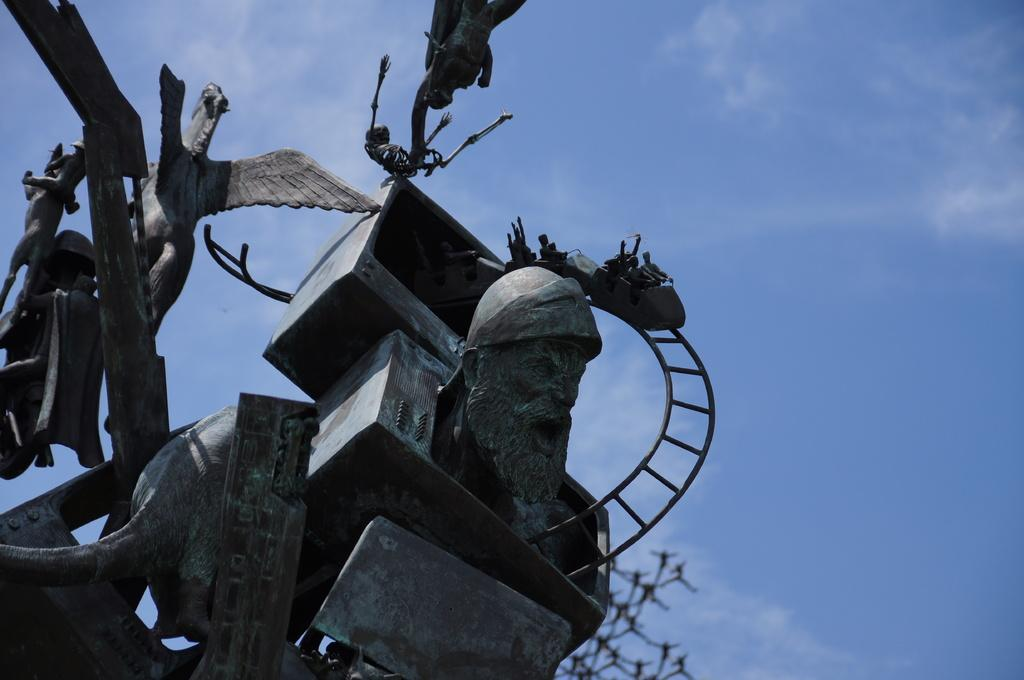What can be seen in the foreground of the image? There are sculptures in the foreground of the image. What is visible in the background of the image? The sky is visible in the background of the image. Are there any additional features in the background? Yes, there are clouds in the background of the image. How much payment is required to enter the bushes in the image? There are no bushes present in the image, and therefore no payment is required. What type of wind can be seen blowing the sculptures in the image? There is no wind or blowing force visible in the image; the sculptures are stationary. 